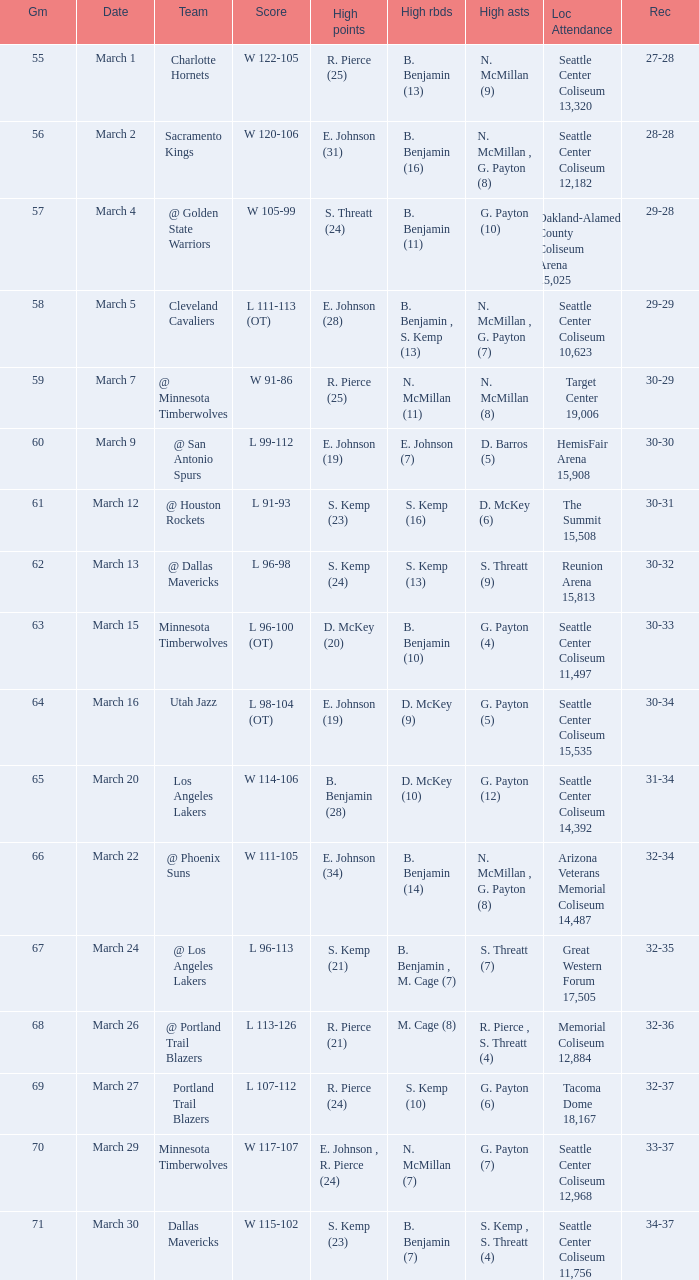WhichScore has a Location Attendance of seattle center coliseum 11,497? L 96-100 (OT). 